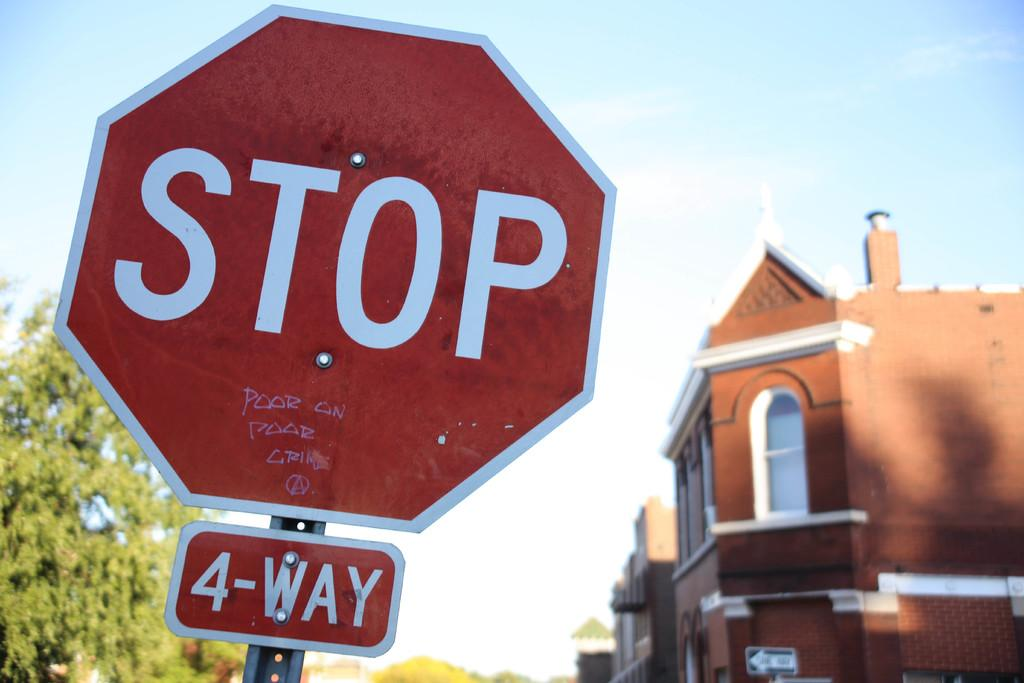<image>
Summarize the visual content of the image. A four way stop sign with graffiti on the bottom of the sign saying "poor on poor crime" 